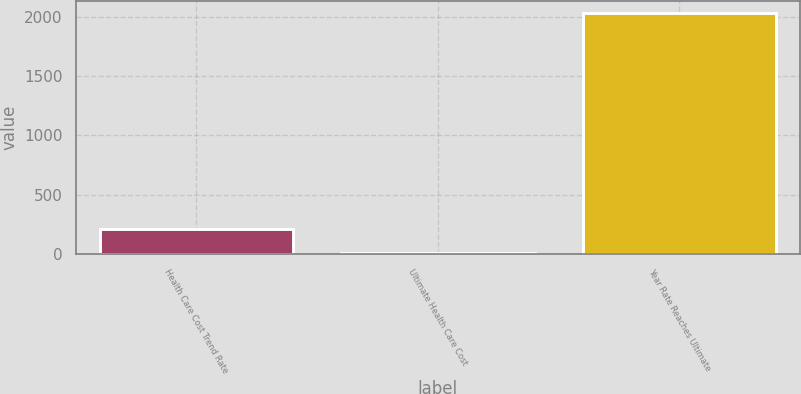<chart> <loc_0><loc_0><loc_500><loc_500><bar_chart><fcel>Health Care Cost Trend Rate<fcel>Ultimate Health Care Cost<fcel>Year Rate Reaches Ultimate<nl><fcel>207.05<fcel>4.5<fcel>2030<nl></chart> 